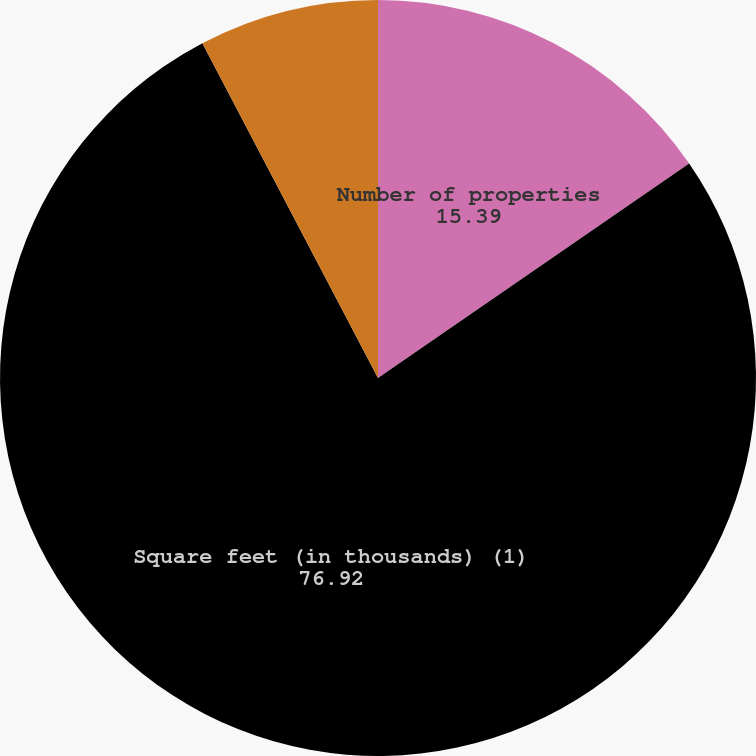Convert chart. <chart><loc_0><loc_0><loc_500><loc_500><pie_chart><fcel>Number of properties<fcel>Square feet (in thousands) (1)<fcel>Average commencement occupancy<fcel>Average rental rate - cash<nl><fcel>15.39%<fcel>76.92%<fcel>7.69%<fcel>0.0%<nl></chart> 